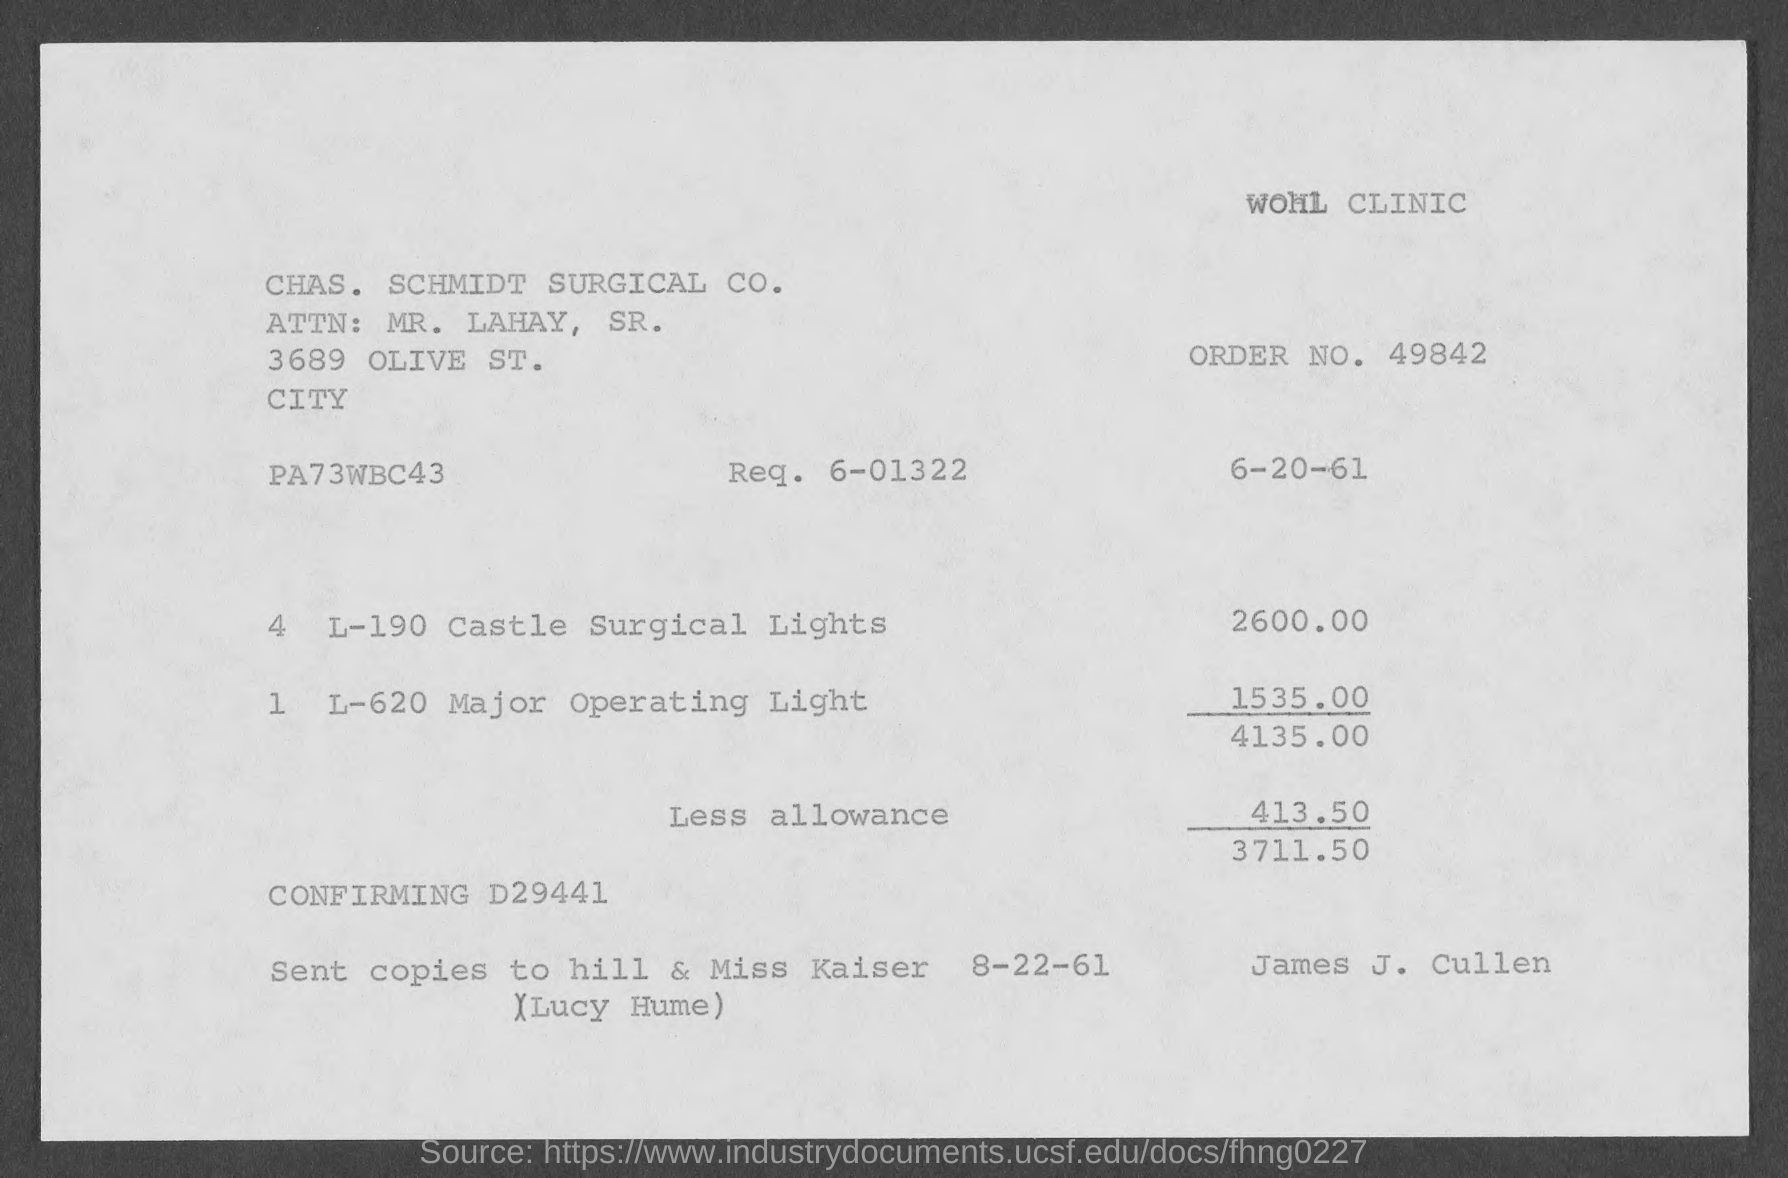what is the amount of less allowance mentioned in the given page ?
 413.50 